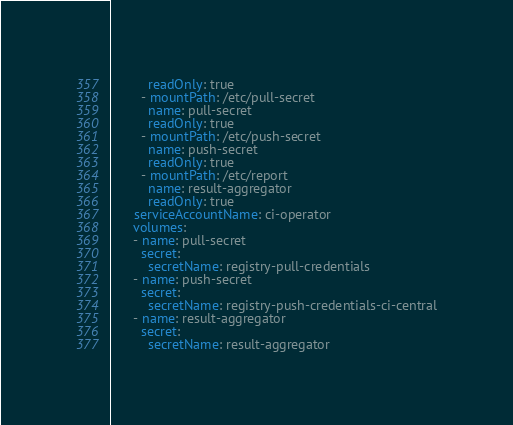<code> <loc_0><loc_0><loc_500><loc_500><_YAML_>          readOnly: true
        - mountPath: /etc/pull-secret
          name: pull-secret
          readOnly: true
        - mountPath: /etc/push-secret
          name: push-secret
          readOnly: true
        - mountPath: /etc/report
          name: result-aggregator
          readOnly: true
      serviceAccountName: ci-operator
      volumes:
      - name: pull-secret
        secret:
          secretName: registry-pull-credentials
      - name: push-secret
        secret:
          secretName: registry-push-credentials-ci-central
      - name: result-aggregator
        secret:
          secretName: result-aggregator
</code> 